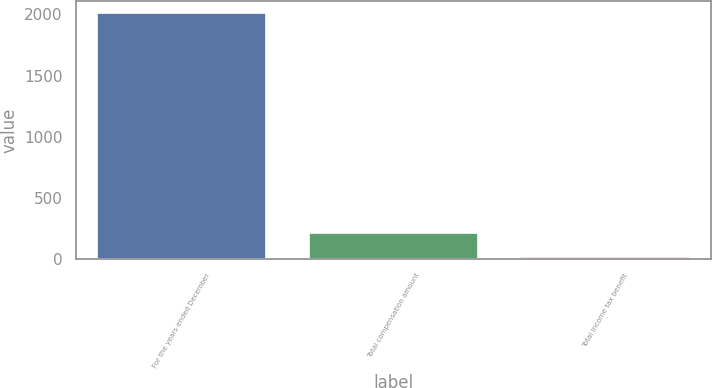<chart> <loc_0><loc_0><loc_500><loc_500><bar_chart><fcel>For the years ended December<fcel>Total compensation amount<fcel>Total income tax benefit<nl><fcel>2010<fcel>216.66<fcel>17.4<nl></chart> 